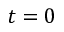<formula> <loc_0><loc_0><loc_500><loc_500>t = 0</formula> 